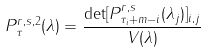Convert formula to latex. <formula><loc_0><loc_0><loc_500><loc_500>P _ { \tau } ^ { r , s , 2 } ( \lambda ) = \frac { \det [ P _ { \tau _ { i } + m - i } ^ { r , s } ( \lambda _ { j } ) ] _ { i , j } } { V ( \lambda ) }</formula> 